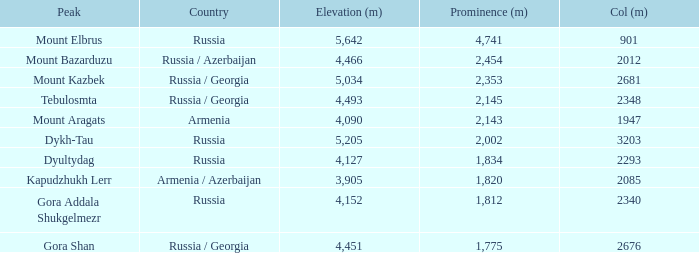With a Col (m) larger than 2012, what is Mount Kazbek's Prominence (m)? 2353.0. I'm looking to parse the entire table for insights. Could you assist me with that? {'header': ['Peak', 'Country', 'Elevation (m)', 'Prominence (m)', 'Col (m)'], 'rows': [['Mount Elbrus', 'Russia', '5,642', '4,741', '901'], ['Mount Bazarduzu', 'Russia / Azerbaijan', '4,466', '2,454', '2012'], ['Mount Kazbek', 'Russia / Georgia', '5,034', '2,353', '2681'], ['Tebulosmta', 'Russia / Georgia', '4,493', '2,145', '2348'], ['Mount Aragats', 'Armenia', '4,090', '2,143', '1947'], ['Dykh-Tau', 'Russia', '5,205', '2,002', '3203'], ['Dyultydag', 'Russia', '4,127', '1,834', '2293'], ['Kapudzhukh Lerr', 'Armenia / Azerbaijan', '3,905', '1,820', '2085'], ['Gora Addala Shukgelmezr', 'Russia', '4,152', '1,812', '2340'], ['Gora Shan', 'Russia / Georgia', '4,451', '1,775', '2676']]} 